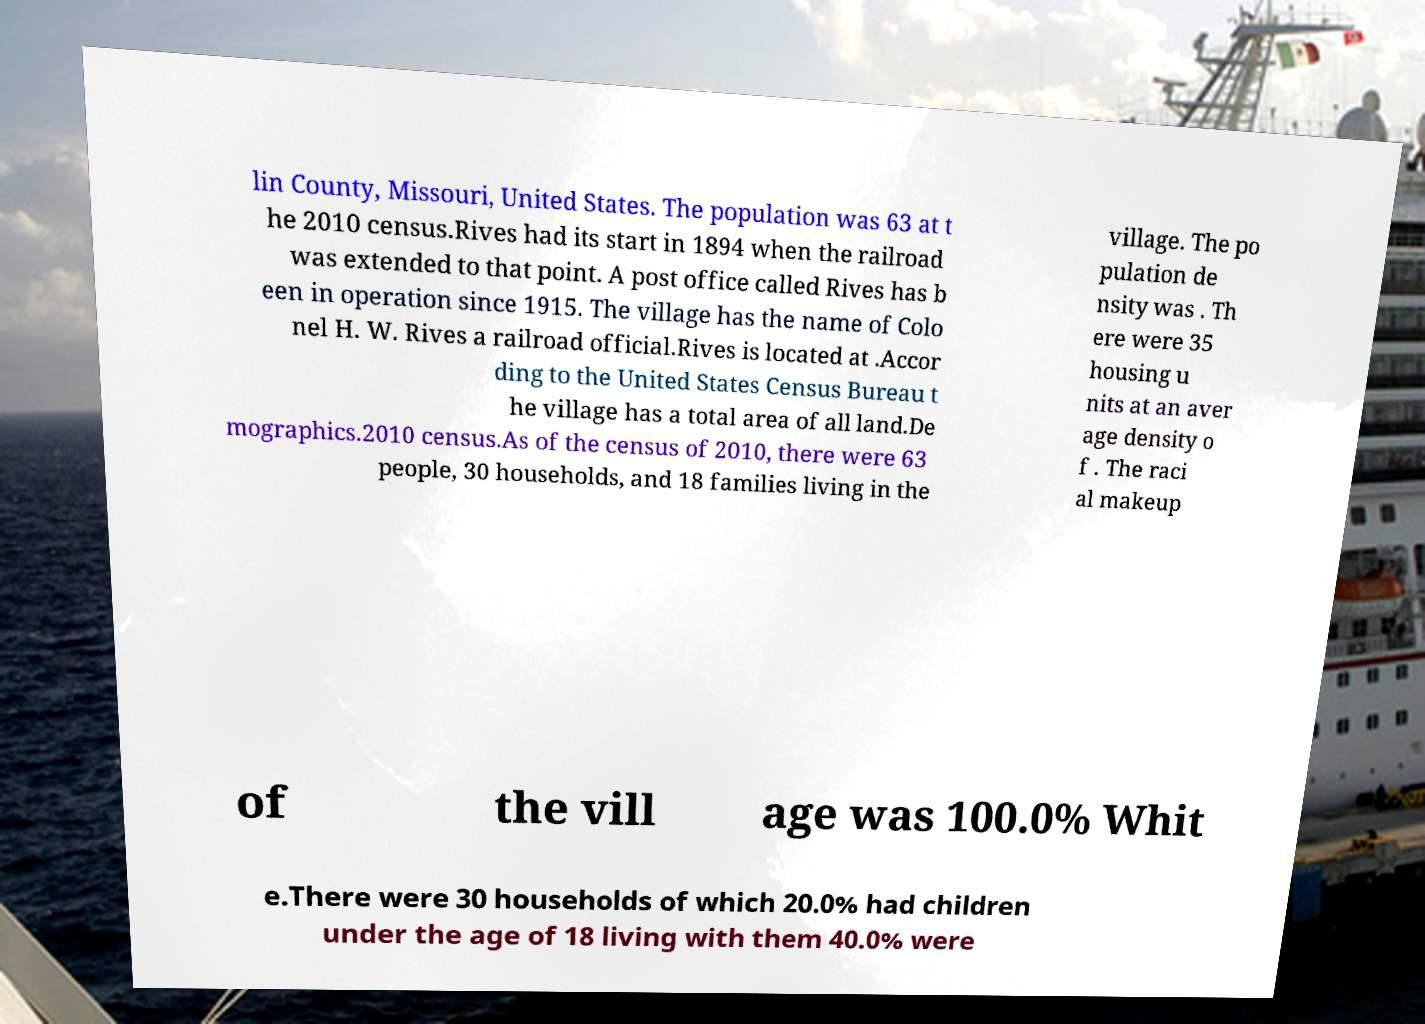For documentation purposes, I need the text within this image transcribed. Could you provide that? lin County, Missouri, United States. The population was 63 at t he 2010 census.Rives had its start in 1894 when the railroad was extended to that point. A post office called Rives has b een in operation since 1915. The village has the name of Colo nel H. W. Rives a railroad official.Rives is located at .Accor ding to the United States Census Bureau t he village has a total area of all land.De mographics.2010 census.As of the census of 2010, there were 63 people, 30 households, and 18 families living in the village. The po pulation de nsity was . Th ere were 35 housing u nits at an aver age density o f . The raci al makeup of the vill age was 100.0% Whit e.There were 30 households of which 20.0% had children under the age of 18 living with them 40.0% were 